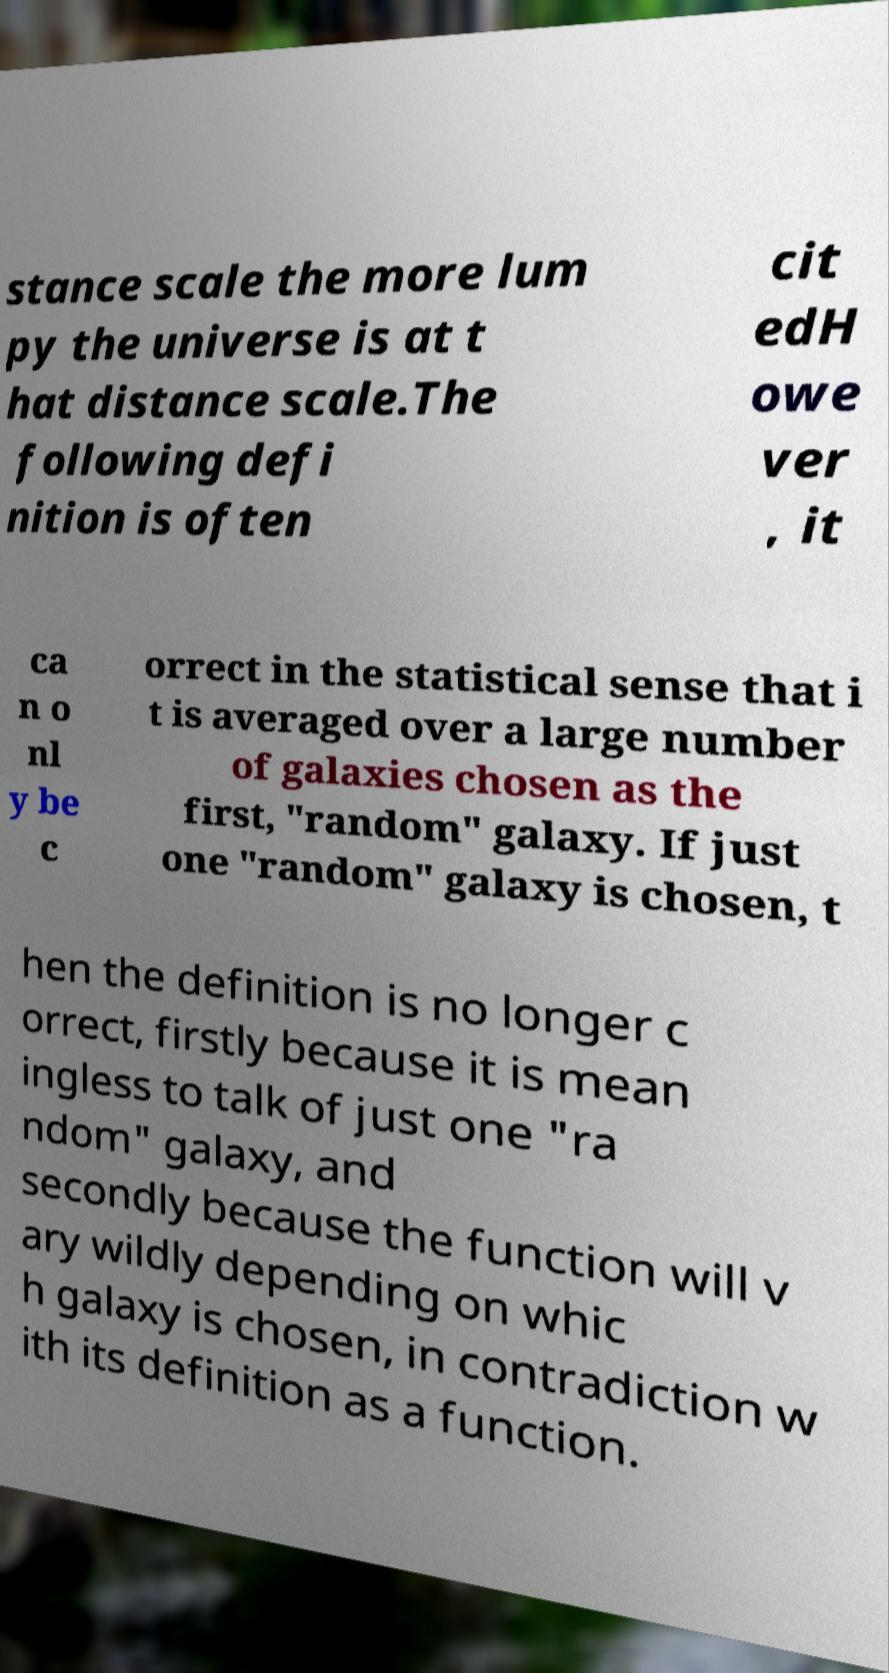Can you read and provide the text displayed in the image?This photo seems to have some interesting text. Can you extract and type it out for me? stance scale the more lum py the universe is at t hat distance scale.The following defi nition is often cit edH owe ver , it ca n o nl y be c orrect in the statistical sense that i t is averaged over a large number of galaxies chosen as the first, "random" galaxy. If just one "random" galaxy is chosen, t hen the definition is no longer c orrect, firstly because it is mean ingless to talk of just one "ra ndom" galaxy, and secondly because the function will v ary wildly depending on whic h galaxy is chosen, in contradiction w ith its definition as a function. 